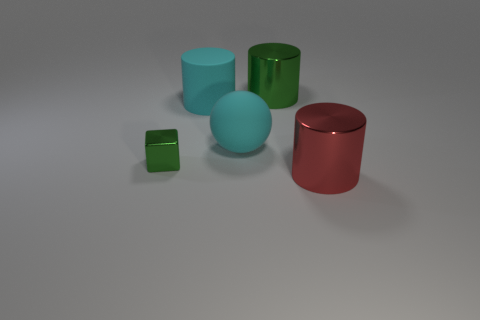Add 2 tiny green shiny cylinders. How many objects exist? 7 Subtract all metallic cylinders. How many cylinders are left? 1 Subtract all red cylinders. How many cylinders are left? 2 Subtract all blocks. How many objects are left? 4 Subtract all red cubes. How many purple balls are left? 0 Subtract all red things. Subtract all cyan rubber balls. How many objects are left? 3 Add 1 cubes. How many cubes are left? 2 Add 4 rubber things. How many rubber things exist? 6 Subtract 0 blue cubes. How many objects are left? 5 Subtract all cyan cylinders. Subtract all brown blocks. How many cylinders are left? 2 